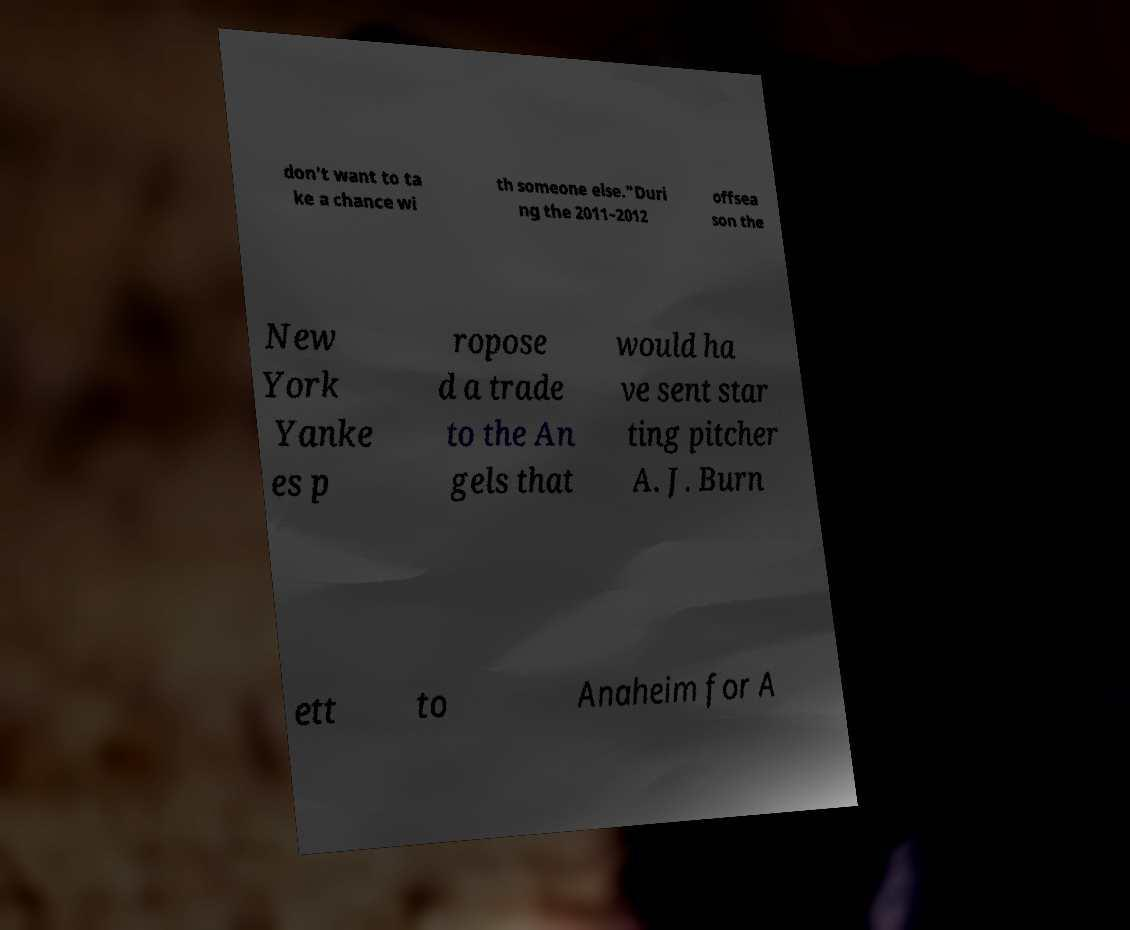I need the written content from this picture converted into text. Can you do that? don't want to ta ke a chance wi th someone else."Duri ng the 2011–2012 offsea son the New York Yanke es p ropose d a trade to the An gels that would ha ve sent star ting pitcher A. J. Burn ett to Anaheim for A 